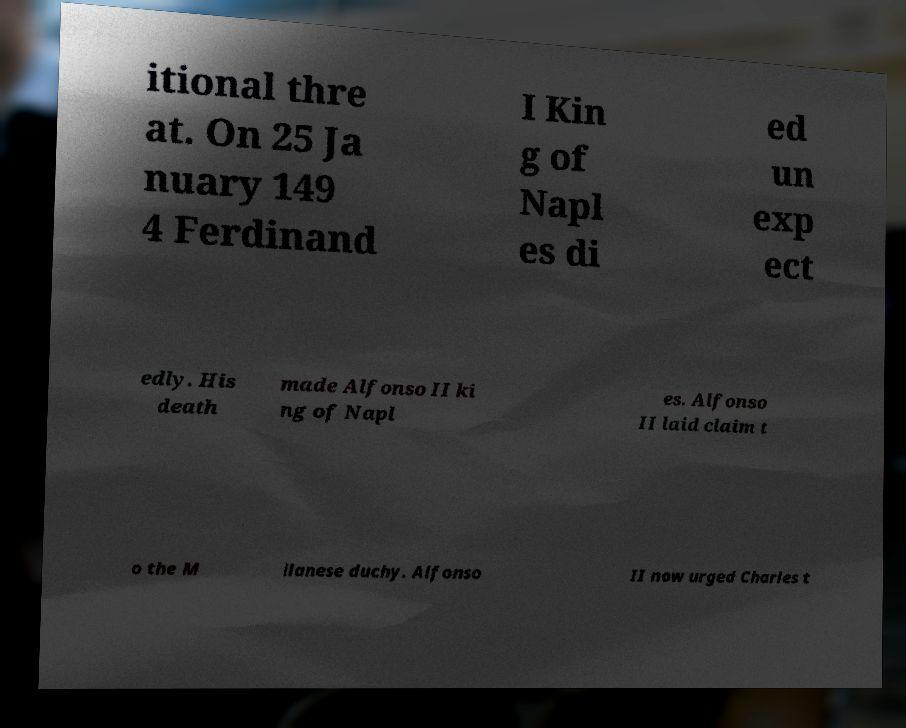Please identify and transcribe the text found in this image. itional thre at. On 25 Ja nuary 149 4 Ferdinand I Kin g of Napl es di ed un exp ect edly. His death made Alfonso II ki ng of Napl es. Alfonso II laid claim t o the M ilanese duchy. Alfonso II now urged Charles t 